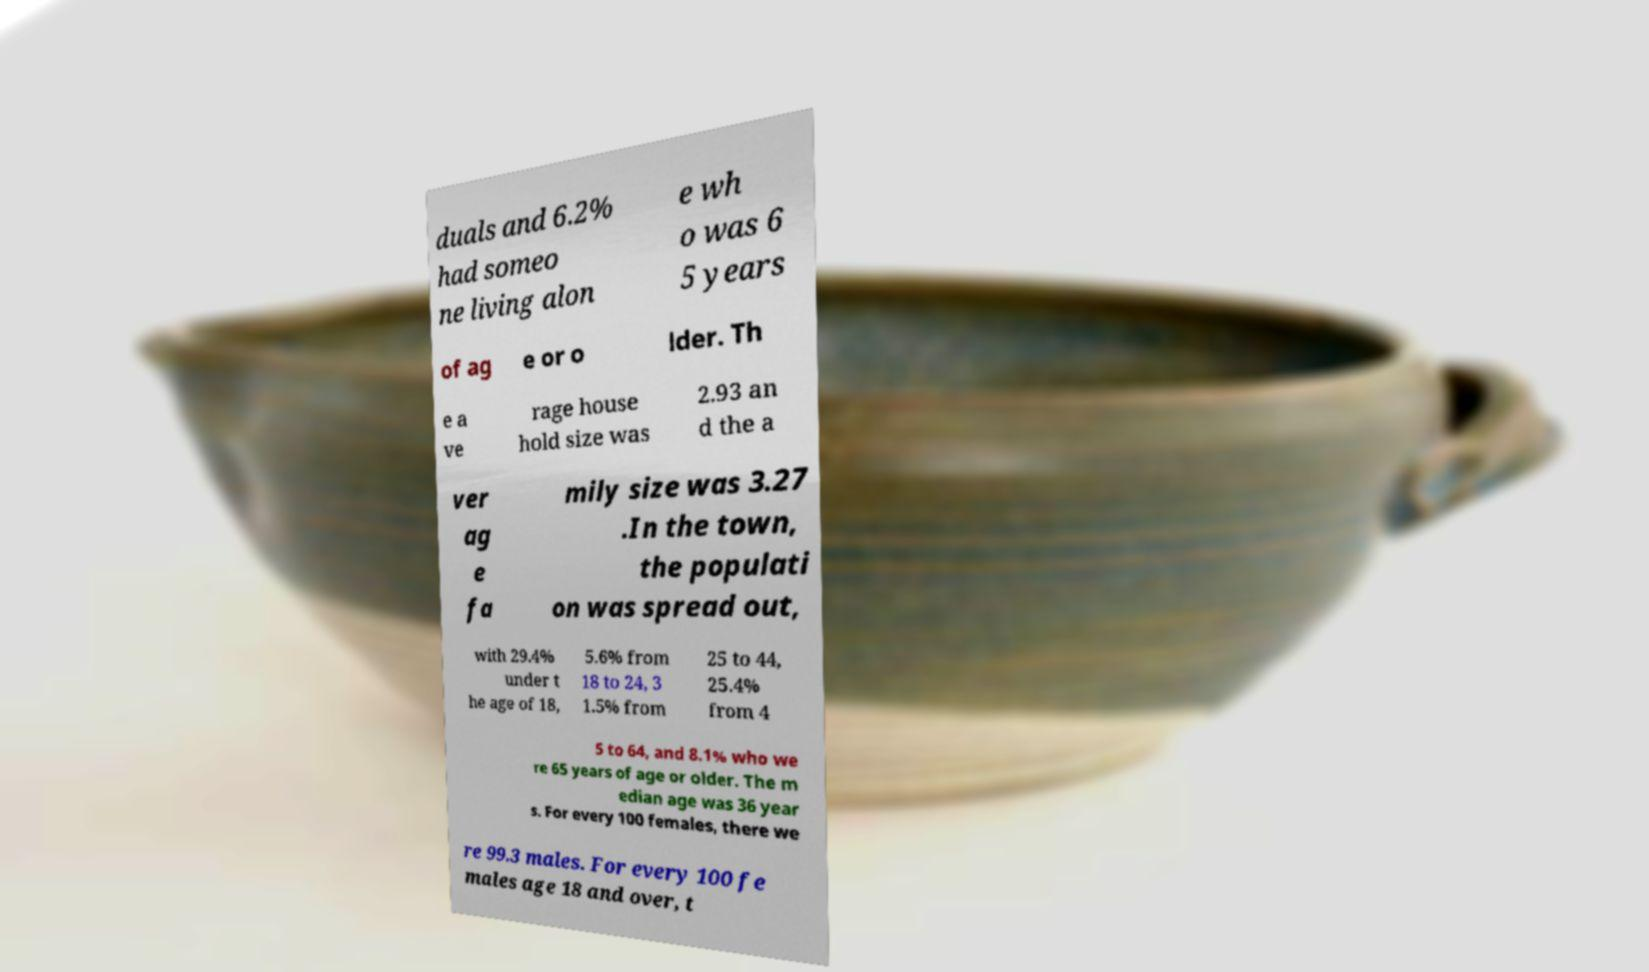Please identify and transcribe the text found in this image. duals and 6.2% had someo ne living alon e wh o was 6 5 years of ag e or o lder. Th e a ve rage house hold size was 2.93 an d the a ver ag e fa mily size was 3.27 .In the town, the populati on was spread out, with 29.4% under t he age of 18, 5.6% from 18 to 24, 3 1.5% from 25 to 44, 25.4% from 4 5 to 64, and 8.1% who we re 65 years of age or older. The m edian age was 36 year s. For every 100 females, there we re 99.3 males. For every 100 fe males age 18 and over, t 